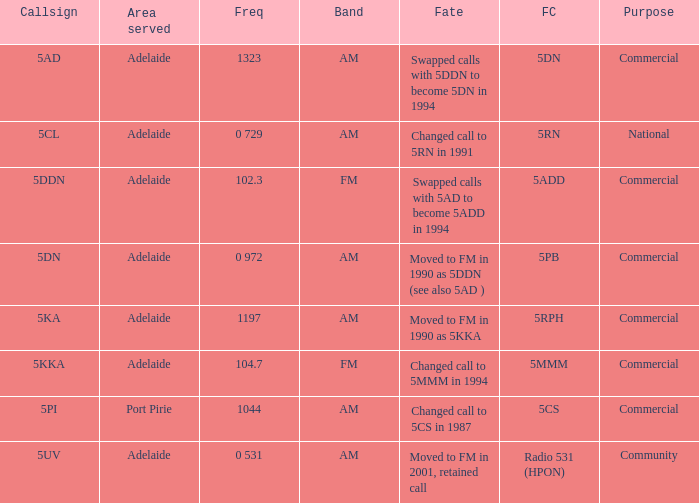Which area served has a Callsign of 5ddn? Adelaide. 